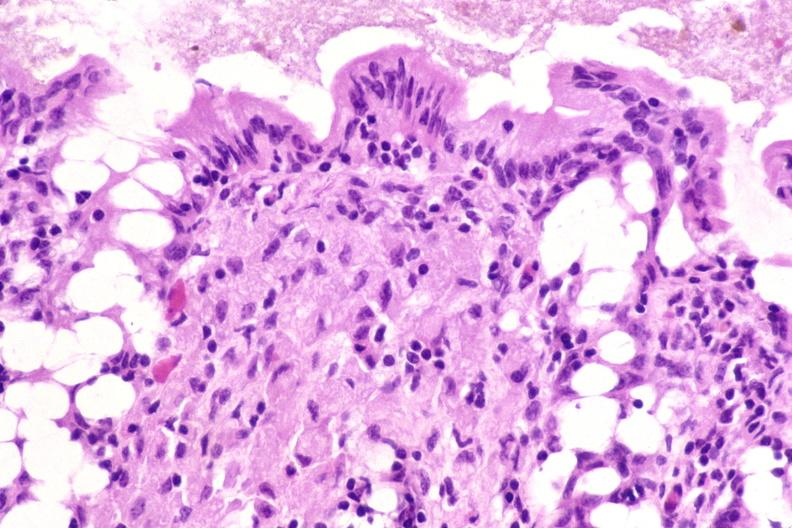what stain?
Answer the question using a single word or phrase. Acid 